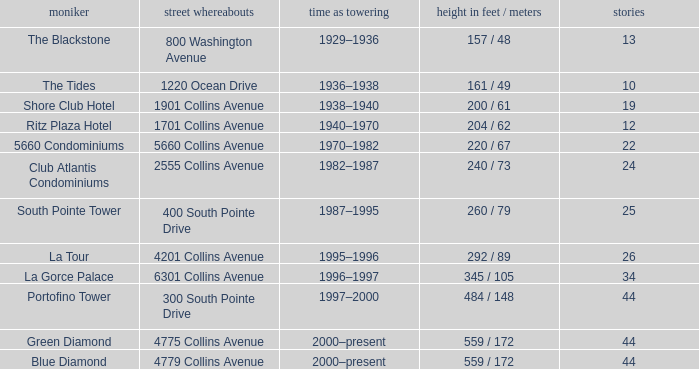What is the height of the Tides with less than 34 floors? 161 / 49. 